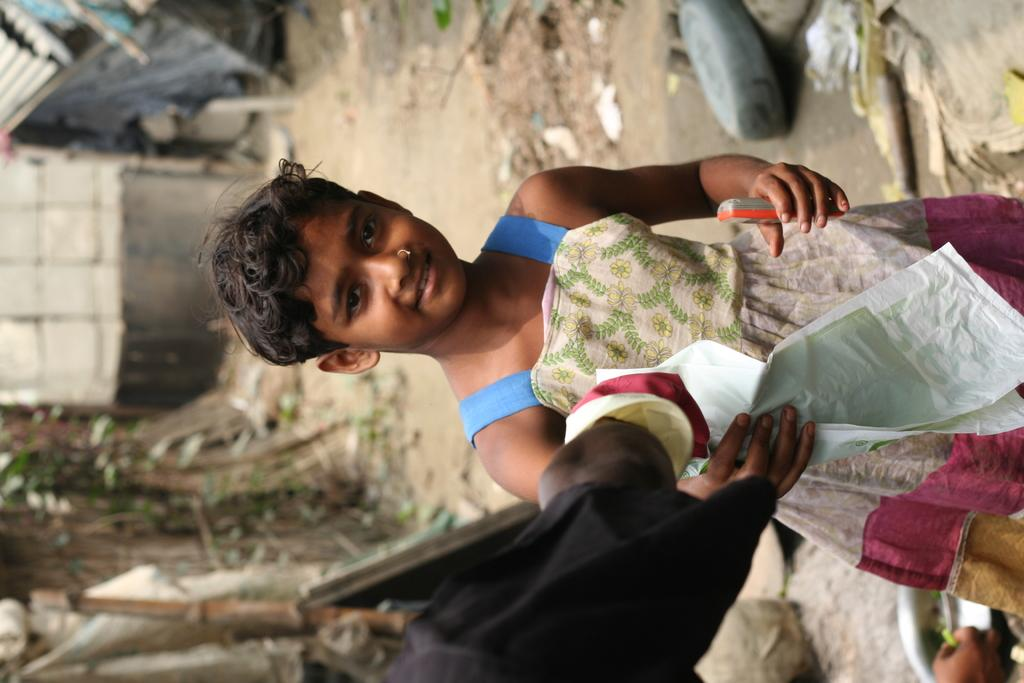What is the main subject in the image? There is a person in the image. What is the person doing in the image? The person is holding something. Can you describe the objects in the image? There are a few objects in the image. What can be said about the background of the image? The background of the image is blurred. How many eyes can be seen on the ball in the image? There is no ball present in the image, so it is not possible to determine the number of eyes on a ball. 